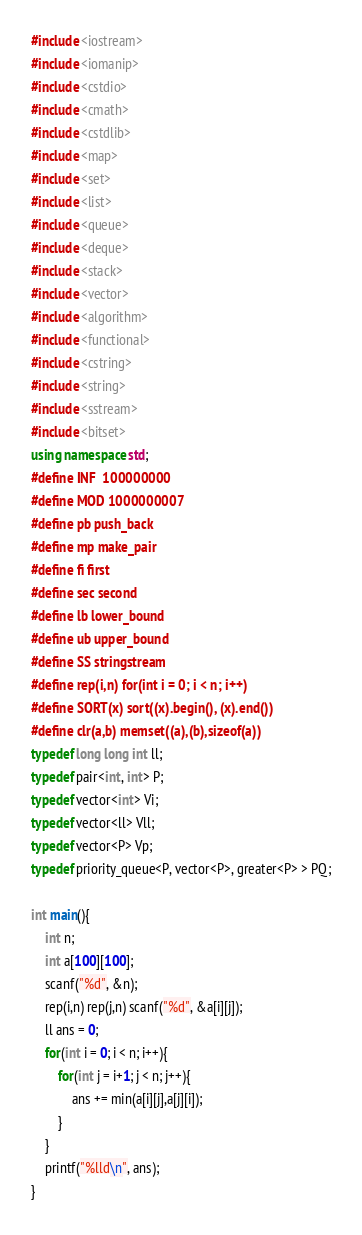Convert code to text. <code><loc_0><loc_0><loc_500><loc_500><_C++_>#include <iostream>
#include <iomanip>
#include <cstdio>
#include <cmath>
#include <cstdlib>
#include <map>
#include <set>
#include <list>
#include <queue>
#include <deque>
#include <stack>
#include <vector>
#include <algorithm>
#include <functional>
#include <cstring>
#include <string>
#include <sstream>
#include <bitset>
using namespace std;
#define INF	100000000
#define MOD 1000000007
#define pb push_back
#define mp make_pair
#define fi first
#define sec second
#define lb lower_bound
#define ub upper_bound
#define SS stringstream
#define rep(i,n) for(int i = 0; i < n; i++)
#define SORT(x) sort((x).begin(), (x).end())
#define clr(a,b) memset((a),(b),sizeof(a))
typedef long long int ll;
typedef pair<int, int> P;
typedef vector<int> Vi;
typedef vector<ll> Vll;
typedef vector<P> Vp;
typedef priority_queue<P, vector<P>, greater<P> > PQ;

int main(){
	int n;
	int a[100][100];
	scanf("%d", &n);
	rep(i,n) rep(j,n) scanf("%d", &a[i][j]);
	ll ans = 0;
	for(int i = 0; i < n; i++){
		for(int j = i+1; j < n; j++){
			ans += min(a[i][j],a[j][i]);
		}
	}
	printf("%lld\n", ans);
}</code> 